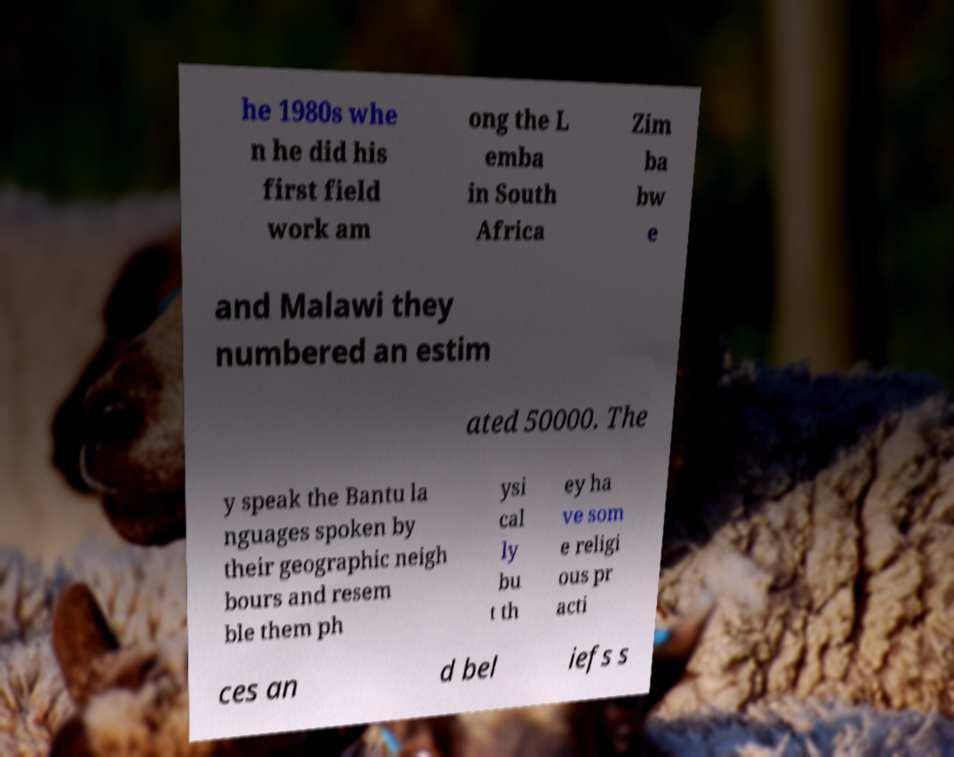Can you accurately transcribe the text from the provided image for me? he 1980s whe n he did his first field work am ong the L emba in South Africa Zim ba bw e and Malawi they numbered an estim ated 50000. The y speak the Bantu la nguages spoken by their geographic neigh bours and resem ble them ph ysi cal ly bu t th ey ha ve som e religi ous pr acti ces an d bel iefs s 